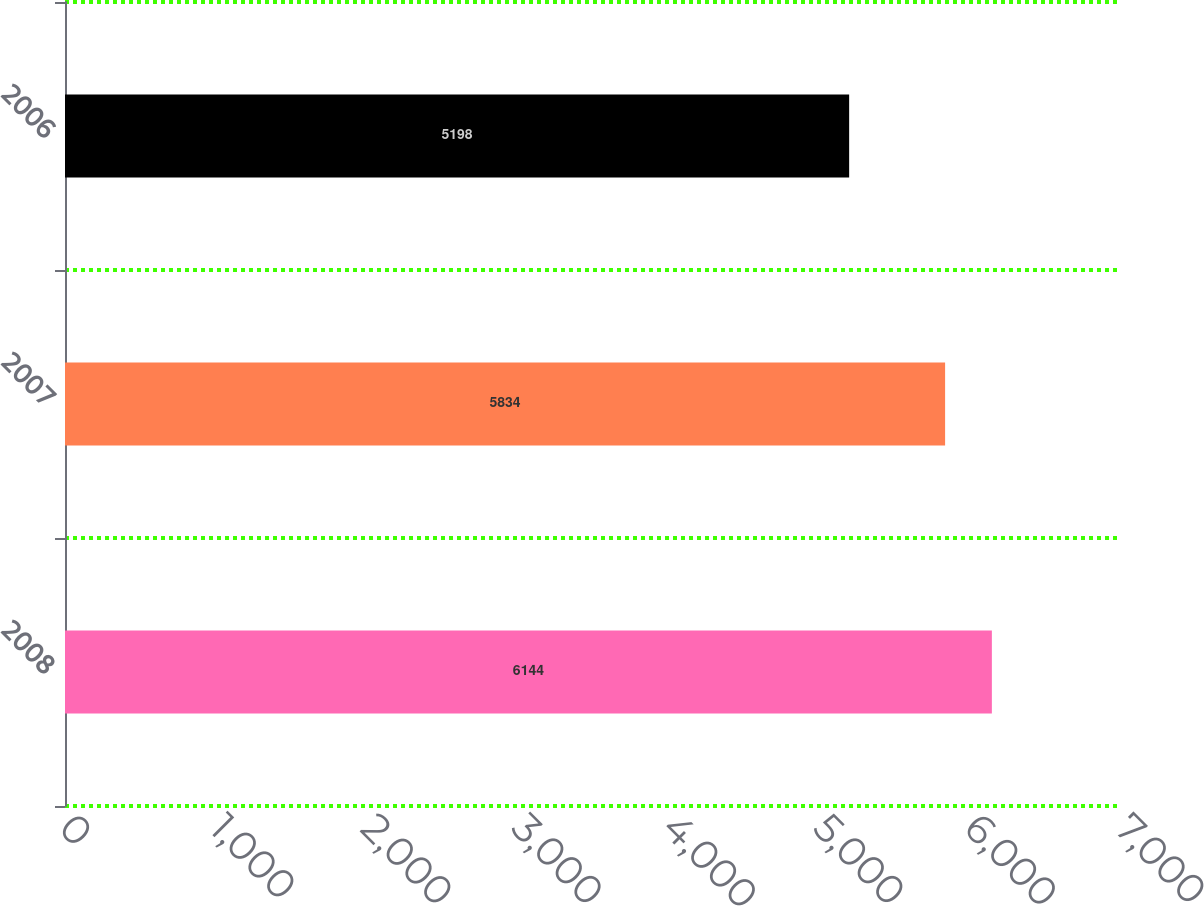Convert chart to OTSL. <chart><loc_0><loc_0><loc_500><loc_500><bar_chart><fcel>2008<fcel>2007<fcel>2006<nl><fcel>6144<fcel>5834<fcel>5198<nl></chart> 